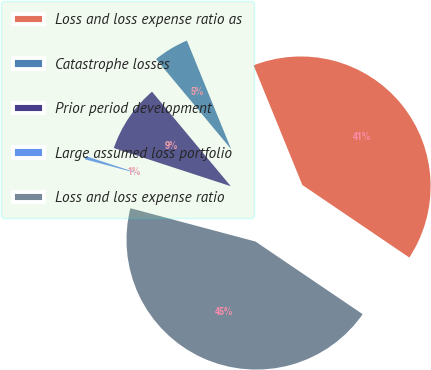<chart> <loc_0><loc_0><loc_500><loc_500><pie_chart><fcel>Loss and loss expense ratio as<fcel>Catastrophe losses<fcel>Prior period development<fcel>Large assumed loss portfolio<fcel>Loss and loss expense ratio<nl><fcel>40.64%<fcel>4.9%<fcel>8.92%<fcel>0.88%<fcel>44.66%<nl></chart> 